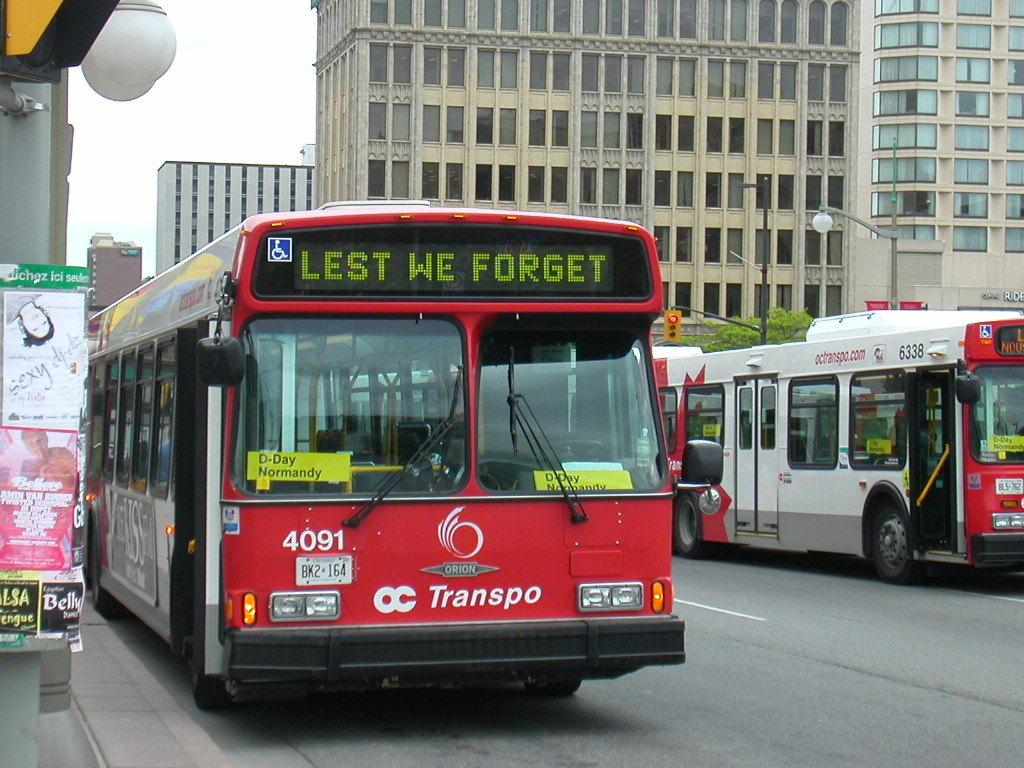What type of vehicles are on the road in the image? There are buses on the road in the image. What structures are located near the buses? There are buildings beside the buses. What additional object can be seen in the image? There is a notice board in the image. How many firemen are visible on the notice board in the image? There are no firemen visible on the notice board in the image. What type of fold can be seen in the image? There is no fold present in the image. 